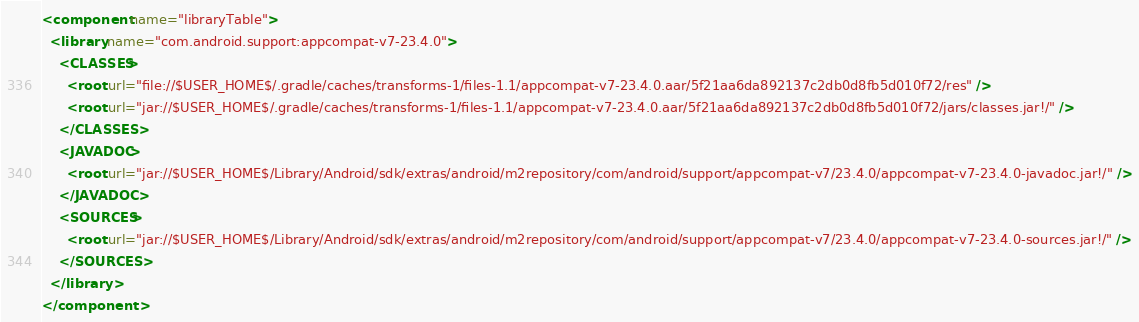<code> <loc_0><loc_0><loc_500><loc_500><_XML_><component name="libraryTable">
  <library name="com.android.support:appcompat-v7-23.4.0">
    <CLASSES>
      <root url="file://$USER_HOME$/.gradle/caches/transforms-1/files-1.1/appcompat-v7-23.4.0.aar/5f21aa6da892137c2db0d8fb5d010f72/res" />
      <root url="jar://$USER_HOME$/.gradle/caches/transforms-1/files-1.1/appcompat-v7-23.4.0.aar/5f21aa6da892137c2db0d8fb5d010f72/jars/classes.jar!/" />
    </CLASSES>
    <JAVADOC>
      <root url="jar://$USER_HOME$/Library/Android/sdk/extras/android/m2repository/com/android/support/appcompat-v7/23.4.0/appcompat-v7-23.4.0-javadoc.jar!/" />
    </JAVADOC>
    <SOURCES>
      <root url="jar://$USER_HOME$/Library/Android/sdk/extras/android/m2repository/com/android/support/appcompat-v7/23.4.0/appcompat-v7-23.4.0-sources.jar!/" />
    </SOURCES>
  </library>
</component></code> 